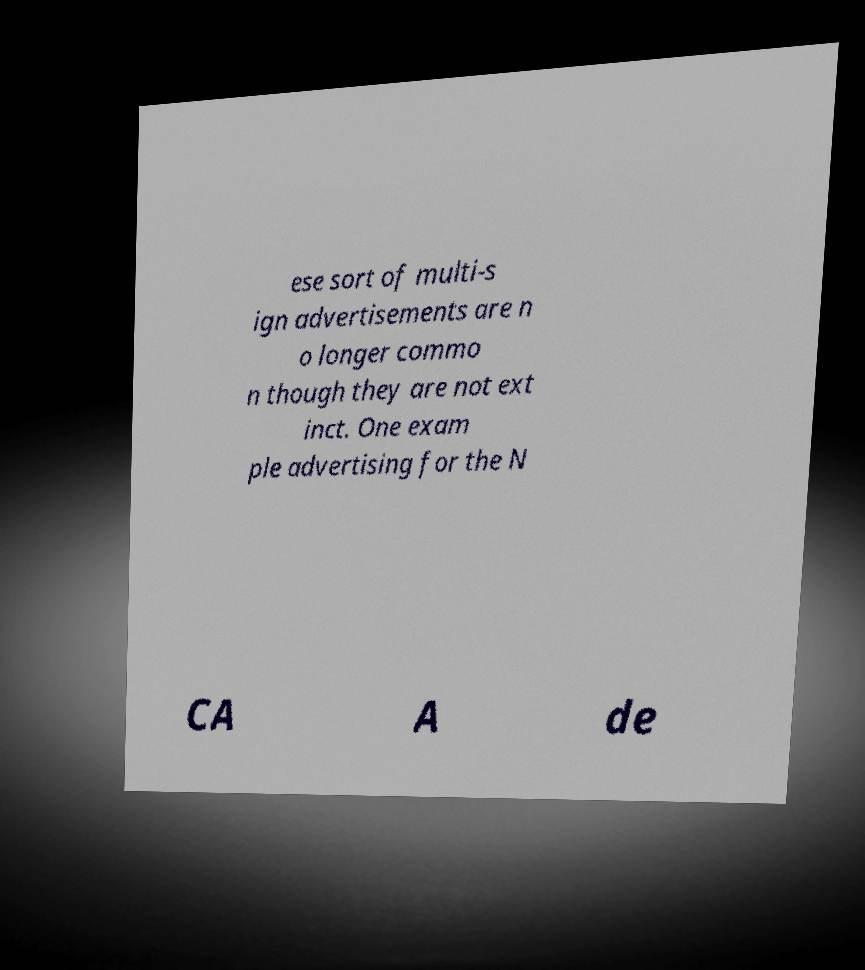There's text embedded in this image that I need extracted. Can you transcribe it verbatim? ese sort of multi-s ign advertisements are n o longer commo n though they are not ext inct. One exam ple advertising for the N CA A de 